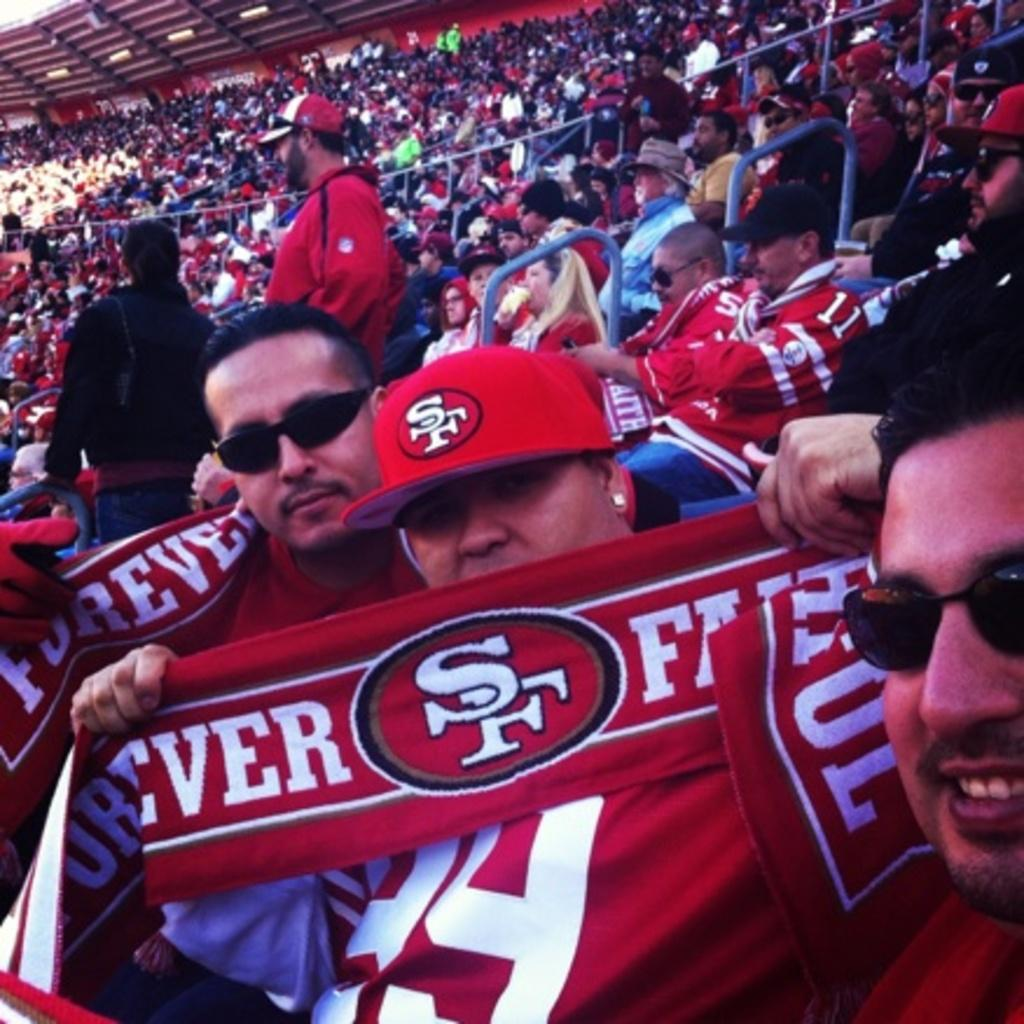<image>
Offer a succinct explanation of the picture presented. A man in the stands holds up a SF banner that is red. 